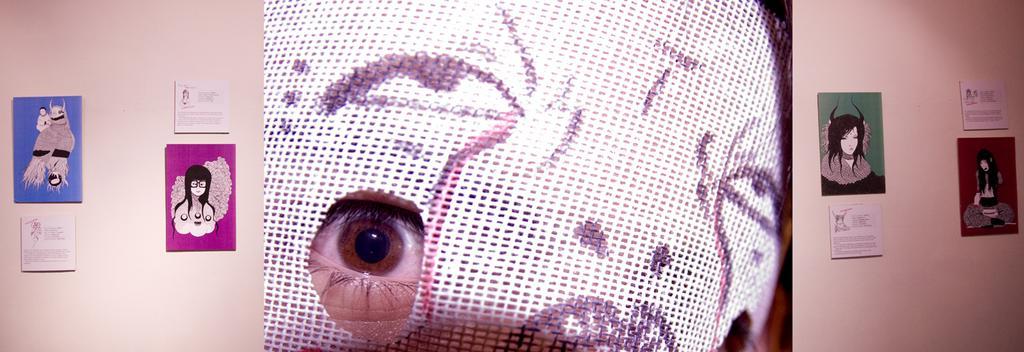In one or two sentences, can you explain what this image depicts? In this image we can see a person wearing mask and wall hangings attached to the wall. 